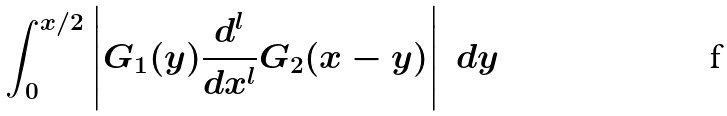<formula> <loc_0><loc_0><loc_500><loc_500>\int _ { 0 } ^ { x / 2 } \left | G _ { 1 } ( y ) \frac { d ^ { l } } { d x ^ { l } } G _ { 2 } ( x - y ) \right | \ d y</formula> 